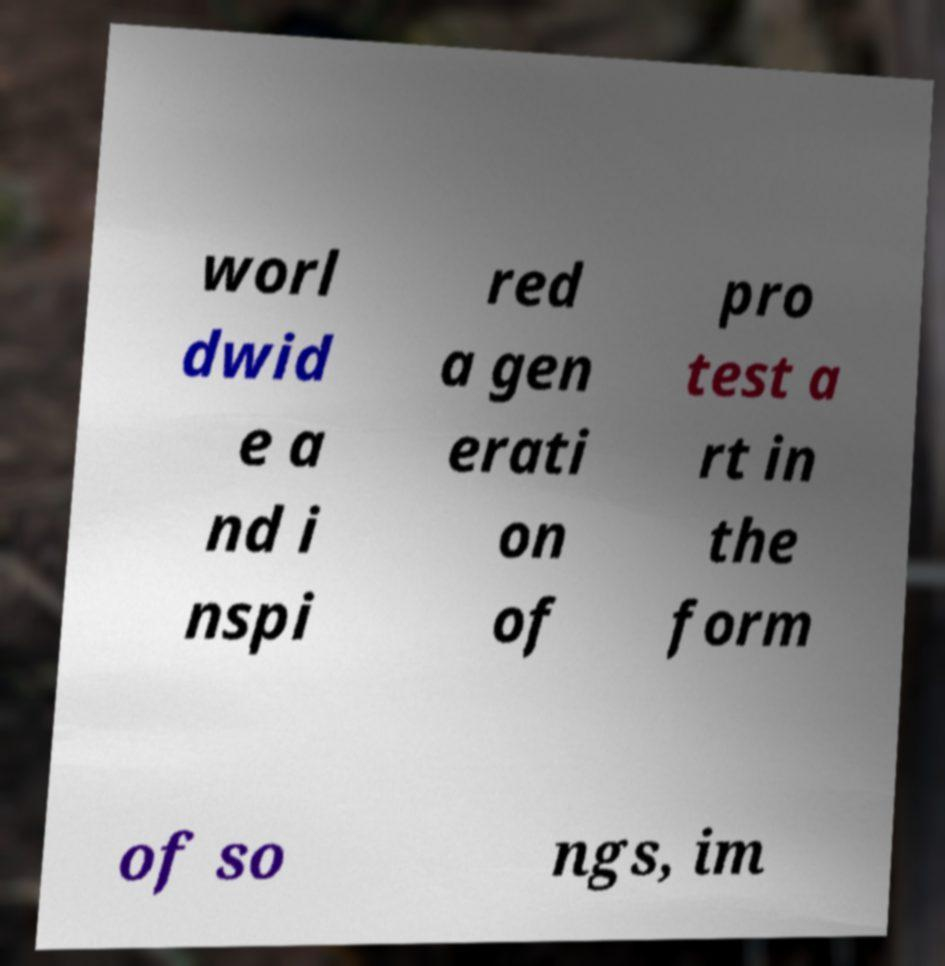Can you accurately transcribe the text from the provided image for me? worl dwid e a nd i nspi red a gen erati on of pro test a rt in the form of so ngs, im 